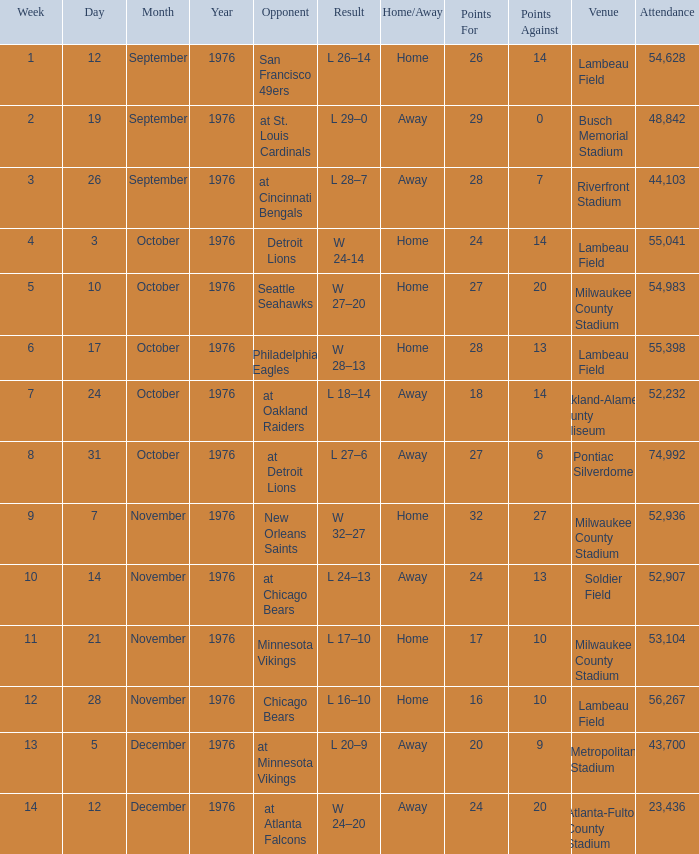How many people attended the game on September 19, 1976? 1.0. 